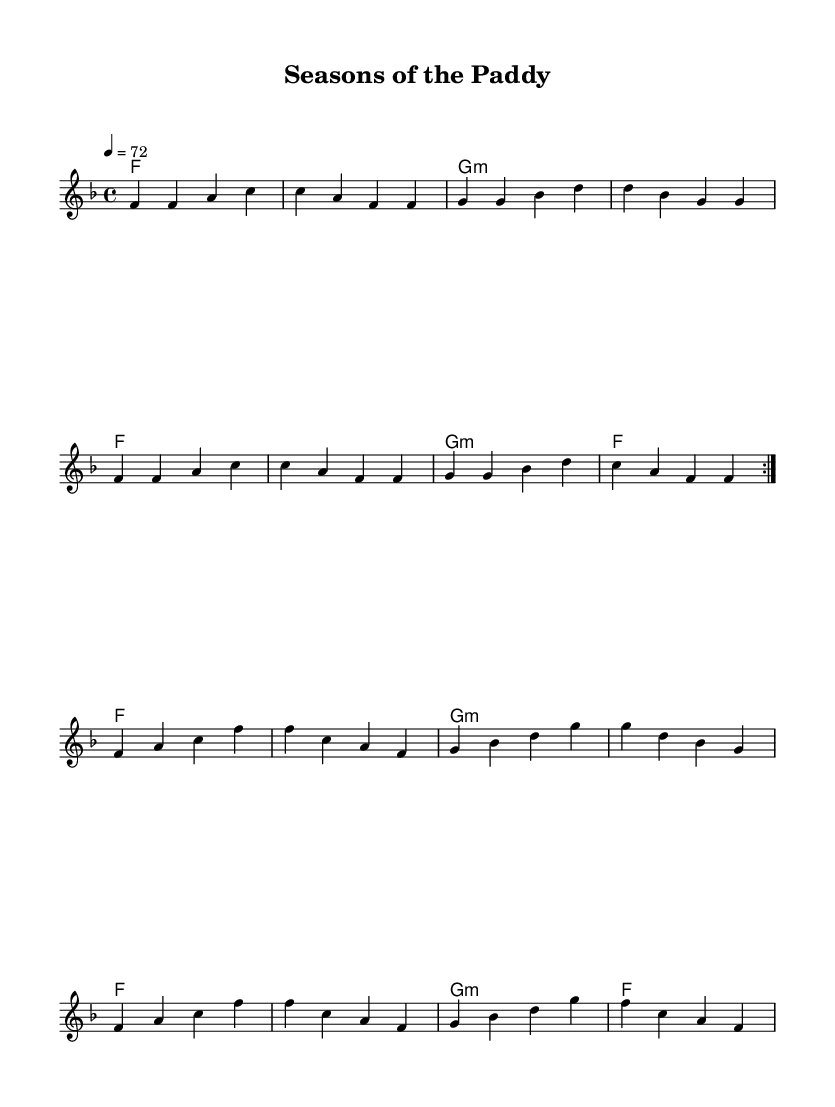What is the key signature of this music? The key signature is F major, which has one flat (B flat). This can be determined by looking at the key signature section at the beginning of the sheet music.
Answer: F major What is the time signature of this music? The time signature is 4/4, which means there are four beats in each measure and a quarter note gets one beat. This is indicated at the beginning of the sheet music.
Answer: 4/4 What tempo marking is indicated in this music? The tempo marking is 72, which means the music should be played at 72 beats per minute. This is found in the tempo indication at the beginning.
Answer: 72 How many measures are there in the repeated section of the melody? In the repeated section of the melody, there are 8 measures. Each measure in the melody line can be counted, with the repeated section being marked accordingly.
Answer: 8 What type of chords are used in the harmonies? The chords used in the harmonies include F major and G minor. The harmony section shows a sequence of these chords that align with the melody.
Answer: F major and G minor What section comes after the first repeated section? The section that comes after the first repeated section is a new melody line beginning with F, followed by a continuation of the chord structure. This can be identified by the "break" marking, indicating a change.
Answer: New melody line What aspect of the music reflects the theme of changing seasons? The melody and harmonies express a range of emotions associated with seasonal changes, which is a common theme in soulful R&B music, reflecting feelings of growth or harvest related to the farming context. This interpretation comes from the overall mood and notes chosen in the composition.
Answer: Emotional expression 